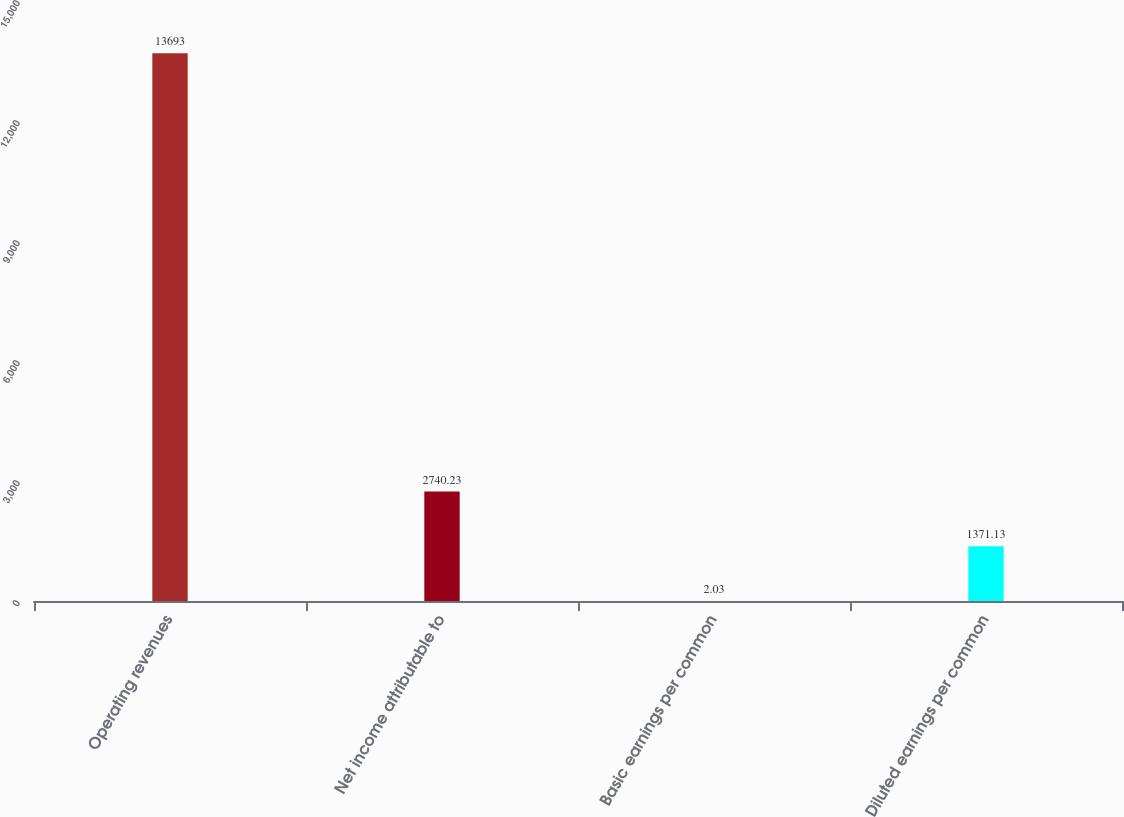Convert chart. <chart><loc_0><loc_0><loc_500><loc_500><bar_chart><fcel>Operating revenues<fcel>Net income attributable to<fcel>Basic earnings per common<fcel>Diluted earnings per common<nl><fcel>13693<fcel>2740.23<fcel>2.03<fcel>1371.13<nl></chart> 